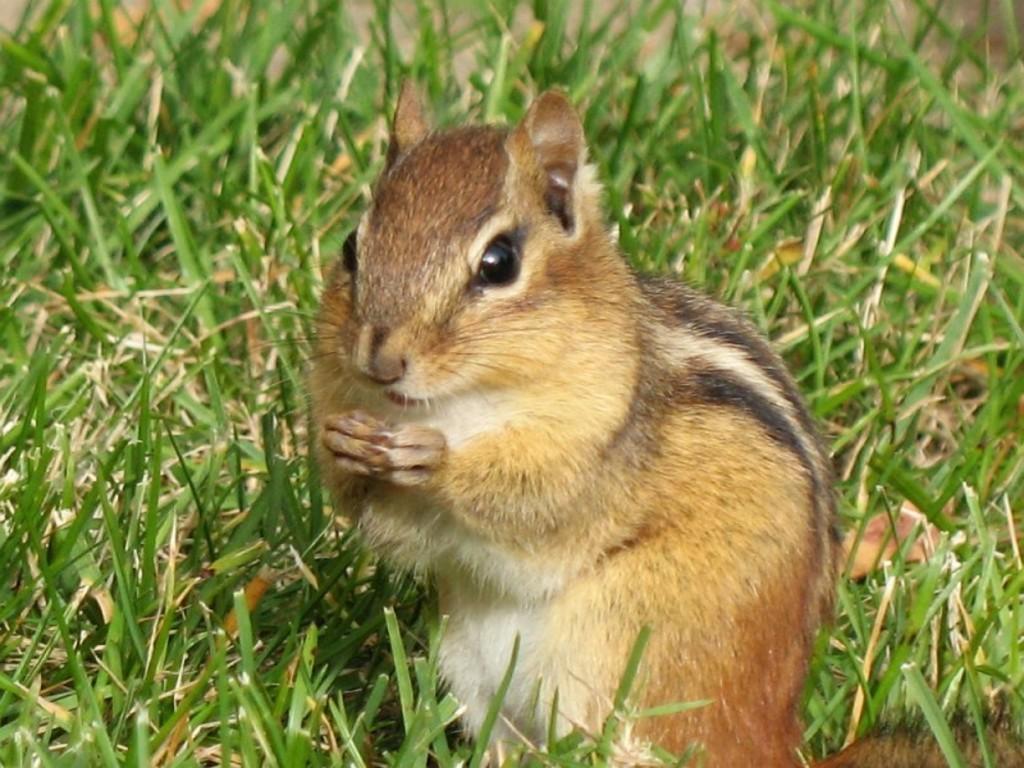How would you summarize this image in a sentence or two? In this image, we can see a squirrel. There is a grass on the ground. 